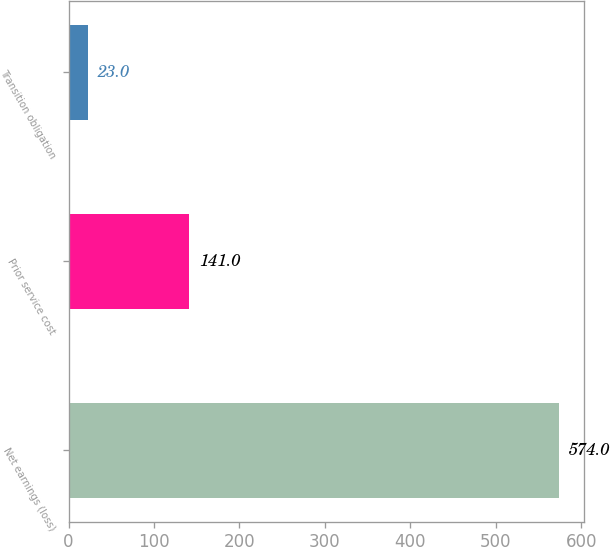<chart> <loc_0><loc_0><loc_500><loc_500><bar_chart><fcel>Net earnings (loss)<fcel>Prior service cost<fcel>Transition obligation<nl><fcel>574<fcel>141<fcel>23<nl></chart> 